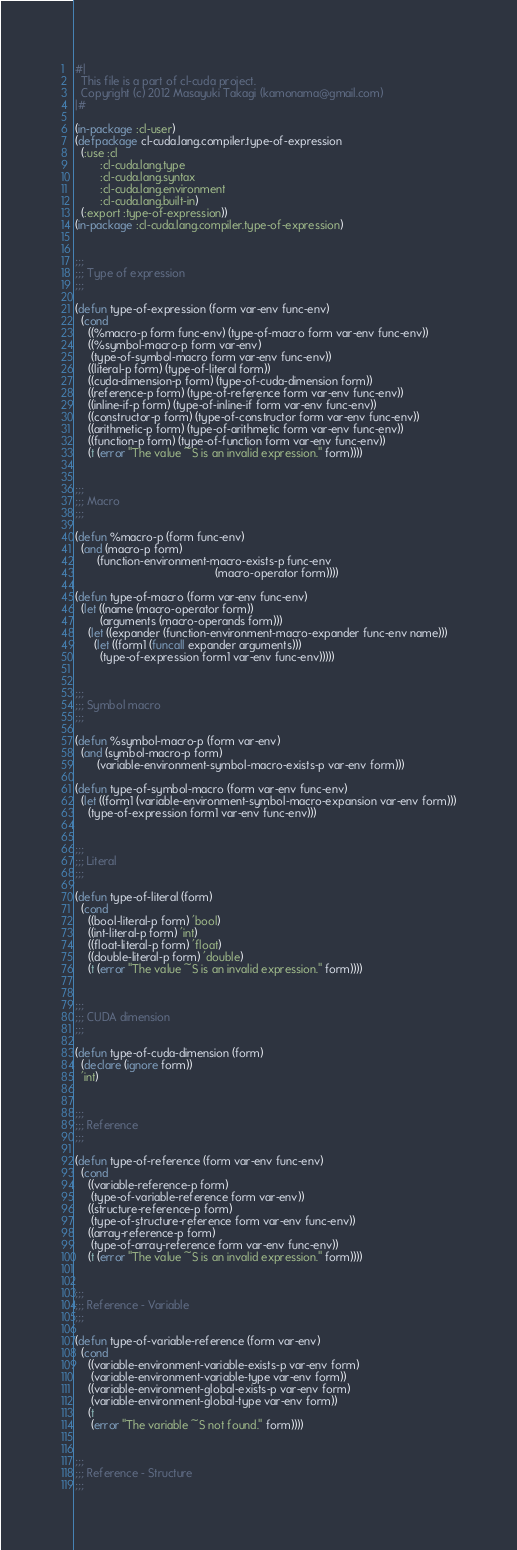Convert code to text. <code><loc_0><loc_0><loc_500><loc_500><_Lisp_>#|
  This file is a part of cl-cuda project.
  Copyright (c) 2012 Masayuki Takagi (kamonama@gmail.com)
|#

(in-package :cl-user)
(defpackage cl-cuda.lang.compiler.type-of-expression
  (:use :cl
        :cl-cuda.lang.type
        :cl-cuda.lang.syntax
        :cl-cuda.lang.environment
        :cl-cuda.lang.built-in)
  (:export :type-of-expression))
(in-package :cl-cuda.lang.compiler.type-of-expression)


;;;
;;; Type of expression
;;;

(defun type-of-expression (form var-env func-env)
  (cond
    ((%macro-p form func-env) (type-of-macro form var-env func-env))
    ((%symbol-macro-p form var-env)
     (type-of-symbol-macro form var-env func-env))
    ((literal-p form) (type-of-literal form))
    ((cuda-dimension-p form) (type-of-cuda-dimension form))
    ((reference-p form) (type-of-reference form var-env func-env))
    ((inline-if-p form) (type-of-inline-if form var-env func-env))
    ((constructor-p form) (type-of-constructor form var-env func-env))
    ((arithmetic-p form) (type-of-arithmetic form var-env func-env))
    ((function-p form) (type-of-function form var-env func-env))
    (t (error "The value ~S is an invalid expression." form))))


;;;
;;; Macro
;;;

(defun %macro-p (form func-env)
  (and (macro-p form)
       (function-environment-macro-exists-p func-env
                                            (macro-operator form))))

(defun type-of-macro (form var-env func-env)
  (let ((name (macro-operator form))
        (arguments (macro-operands form)))
    (let ((expander (function-environment-macro-expander func-env name)))
      (let ((form1 (funcall expander arguments)))
        (type-of-expression form1 var-env func-env)))))


;;;
;;; Symbol macro
;;;

(defun %symbol-macro-p (form var-env)
  (and (symbol-macro-p form)
       (variable-environment-symbol-macro-exists-p var-env form)))

(defun type-of-symbol-macro (form var-env func-env)
  (let ((form1 (variable-environment-symbol-macro-expansion var-env form)))
    (type-of-expression form1 var-env func-env)))


;;;
;;; Literal
;;;

(defun type-of-literal (form)
  (cond
    ((bool-literal-p form) 'bool)
    ((int-literal-p form) 'int)
    ((float-literal-p form) 'float)
    ((double-literal-p form) 'double)
    (t (error "The value ~S is an invalid expression." form))))


;;;
;;; CUDA dimension
;;;

(defun type-of-cuda-dimension (form)
  (declare (ignore form))
  'int)


;;;
;;; Reference
;;;

(defun type-of-reference (form var-env func-env)
  (cond
    ((variable-reference-p form)
     (type-of-variable-reference form var-env))
    ((structure-reference-p form)
     (type-of-structure-reference form var-env func-env))
    ((array-reference-p form)
     (type-of-array-reference form var-env func-env))
    (t (error "The value ~S is an invalid expression." form))))


;;;
;;; Reference - Variable
;;;

(defun type-of-variable-reference (form var-env)
  (cond
    ((variable-environment-variable-exists-p var-env form)
     (variable-environment-variable-type var-env form))
    ((variable-environment-global-exists-p var-env form)
     (variable-environment-global-type var-env form))
    (t
     (error "The variable ~S not found." form))))


;;;
;;; Reference - Structure
;;;
</code> 